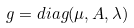Convert formula to latex. <formula><loc_0><loc_0><loc_500><loc_500>g = d i a g ( \mu , A , \lambda )</formula> 